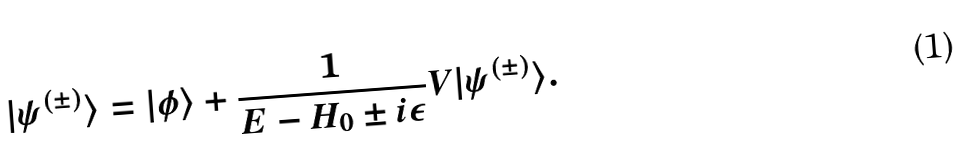Convert formula to latex. <formula><loc_0><loc_0><loc_500><loc_500>| \psi ^ { ( \pm ) } \rangle = | \phi \rangle + { \frac { 1 } { E - H _ { 0 } \pm i \epsilon } } V | \psi ^ { ( \pm ) } \rangle .</formula> 